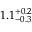<formula> <loc_0><loc_0><loc_500><loc_500>1 . 1 _ { - 0 . 3 } ^ { + 0 . 2 } \, \</formula> 